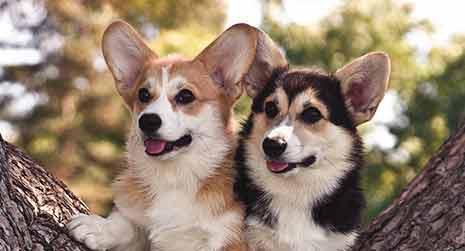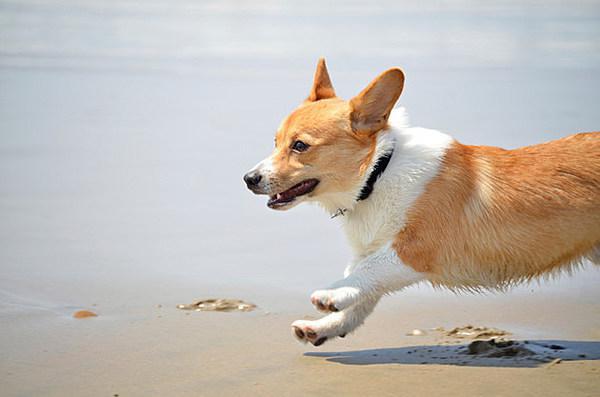The first image is the image on the left, the second image is the image on the right. Considering the images on both sides, is "There is a sitting dog in one of the images." valid? Answer yes or no. No. 